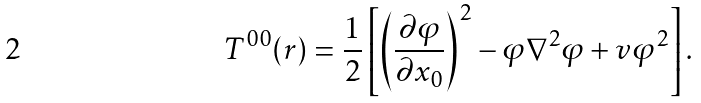<formula> <loc_0><loc_0><loc_500><loc_500>T ^ { 0 0 } ( r ) = \frac { 1 } { 2 } \left [ \left ( \frac { \partial \varphi } { \partial x _ { 0 } } \right ) ^ { 2 } - \varphi \nabla ^ { 2 } \varphi + v \varphi ^ { 2 } \right ] .</formula> 